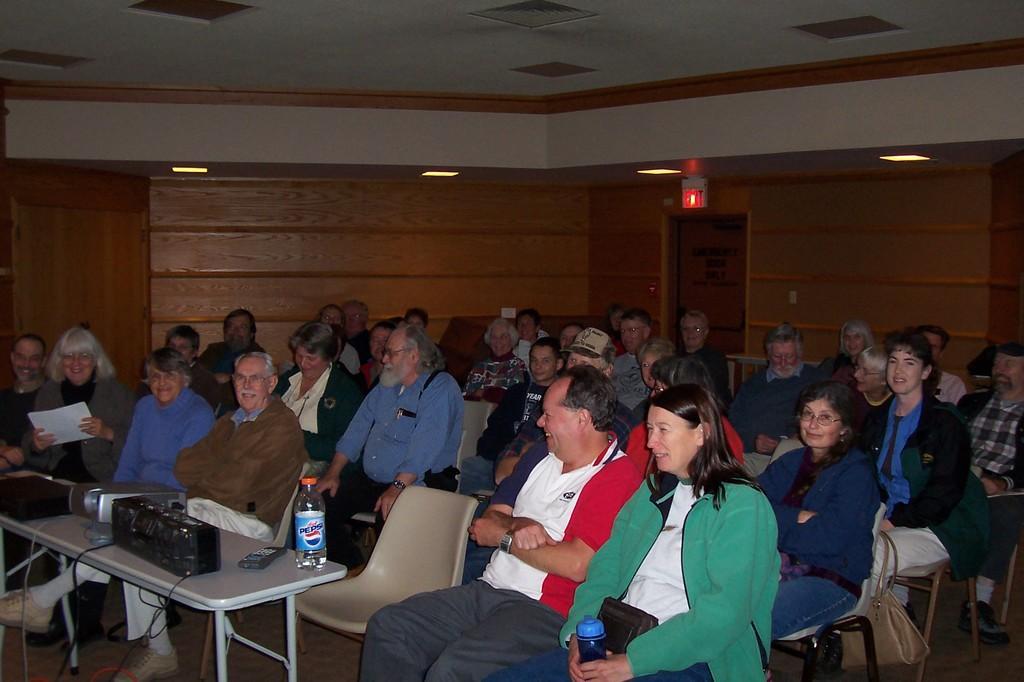Describe this image in one or two sentences. A meeting room where a group of people sitting on the chairs and a projector on the table and also a water bottle on the table. Here the people are listening and also laughing and some are posing for the picture. 